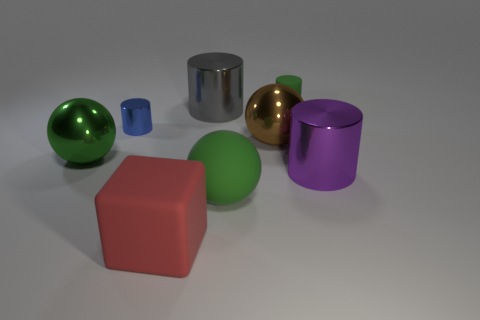What number of matte objects are blue cylinders or blocks?
Give a very brief answer. 1. Is the red object the same size as the purple thing?
Offer a terse response. Yes. Is the number of big brown things right of the purple cylinder less than the number of things right of the large block?
Give a very brief answer. Yes. What is the size of the red thing?
Provide a succinct answer. Large. What number of big things are spheres or gray shiny things?
Keep it short and to the point. 4. There is a green cylinder; is it the same size as the metallic cylinder that is on the left side of the large cube?
Your answer should be compact. Yes. Is there anything else that has the same shape as the big red rubber object?
Ensure brevity in your answer.  No. How many large brown metallic balls are there?
Offer a terse response. 1. How many green objects are big rubber cylinders or small cylinders?
Your response must be concise. 1. Does the big green ball that is left of the big gray cylinder have the same material as the big block?
Provide a short and direct response. No. 